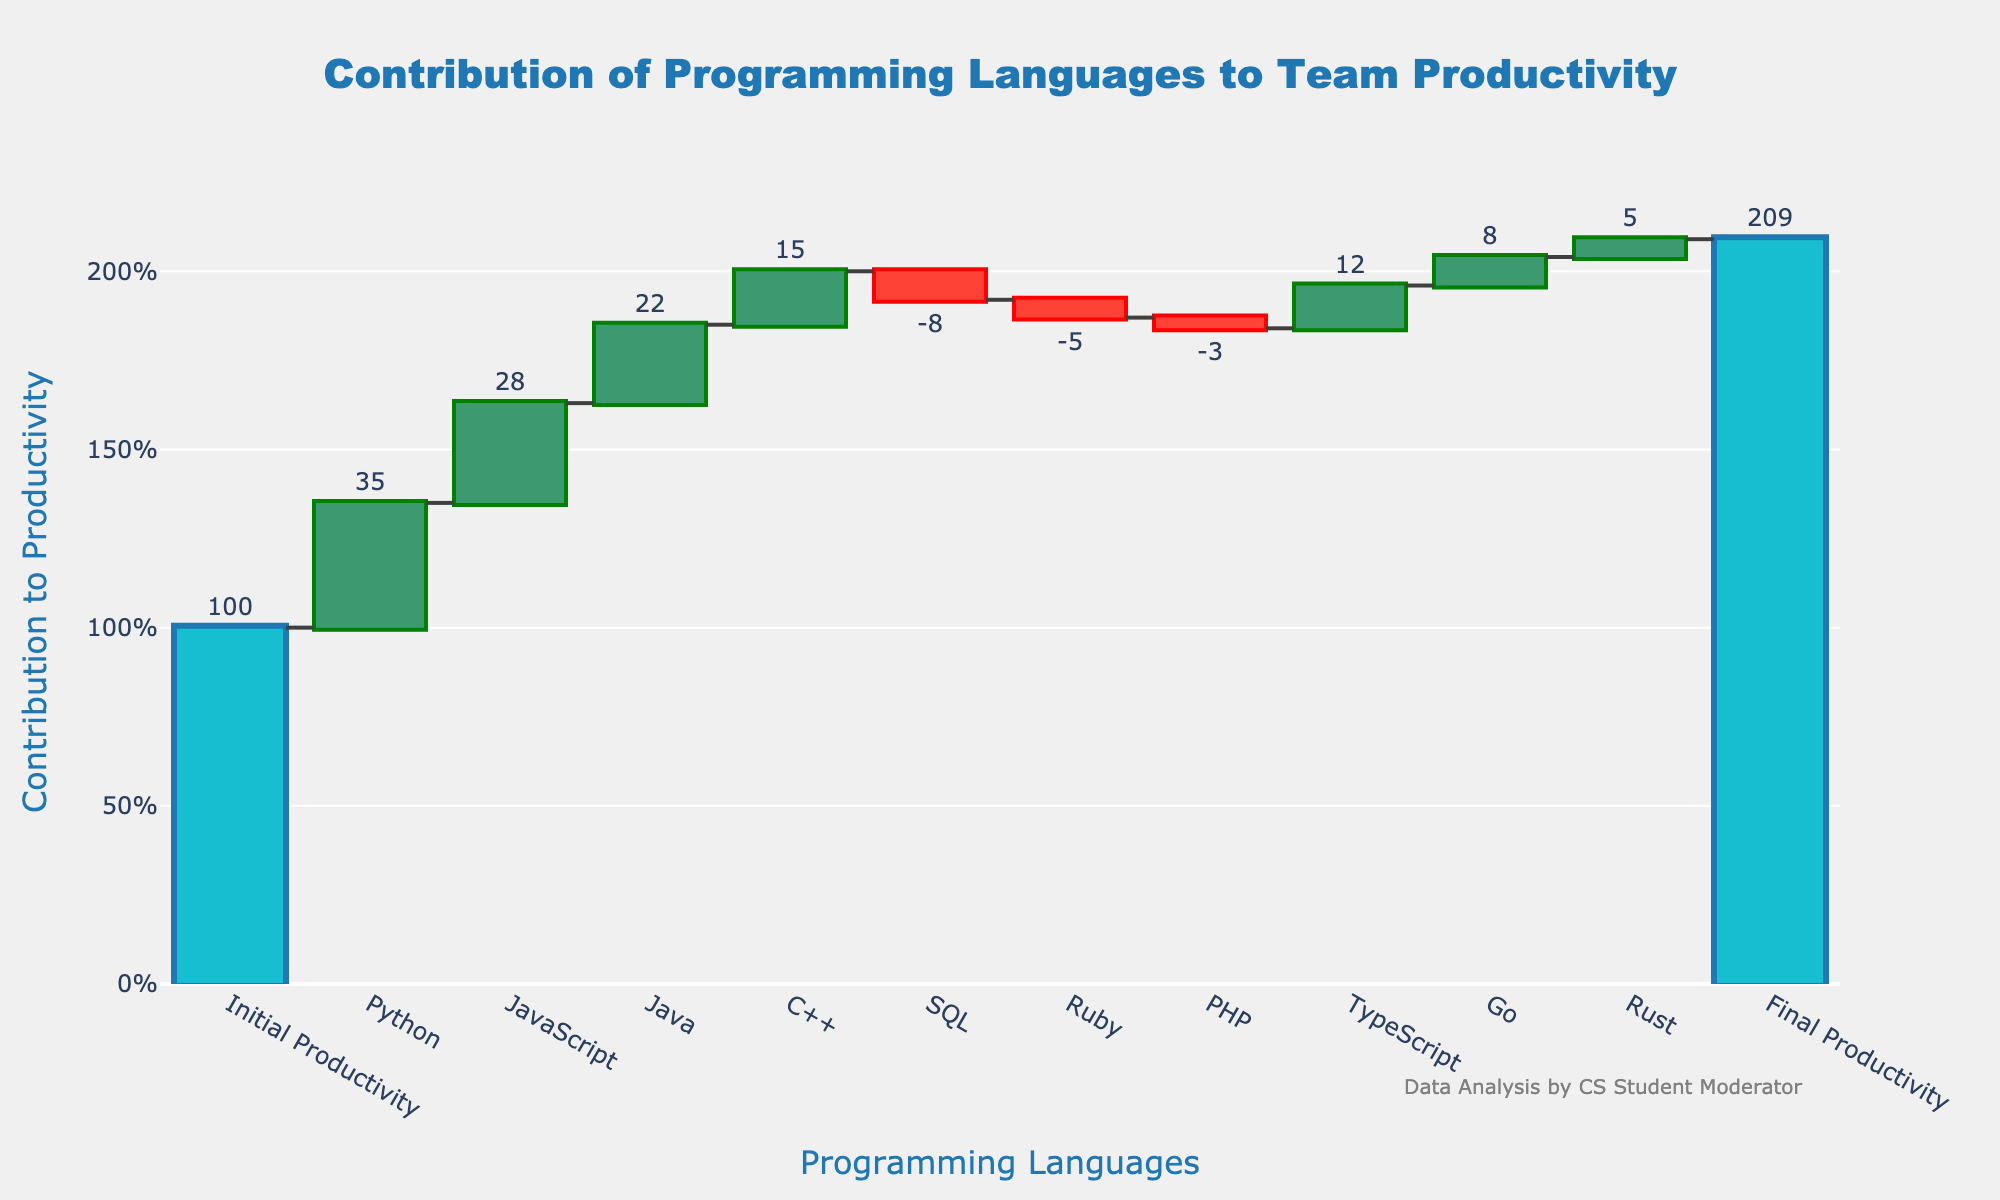What's the title of the chart? The title is usually displayed at the top of the chart. In this case, it states "Contribution of Programming Languages to Team Productivity."
Answer: Contribution of Programming Languages to Team Productivity How many programming languages contributed positively to productivity? To determine this, count the languages with a positive contribution. Listed with a '+' sign are Python, JavaScript, Java, TypeScript, Go, and Rust.
Answer: 6 Which language had the highest negative impact on productivity? The language with the most negative impact will have the largest negative value. SQL contributed -8, which is the greatest negative value.
Answer: SQL What is the difference in contribution between Python and JavaScript? Python's contribution is 35, and JavaScript's is 28. Subtract the smaller from the larger: 35 - 28.
Answer: 7 How does the decrease in productivity from SQL compare to Ruby? SQL decreased productivity by 8, and Ruby by 5. SQL's impact is 3 higher than Ruby's, calculated as 8 - 5.
Answer: 3 What was the team's final productivity value? The final productivity value is indicated as the cumulative total at the end of the Waterfall Chart, labeled "Final Productivity."
Answer: 209 Which language had the second-largest positive contribution to productivity? First, identify the largest positive contributor (Python at 35), then find the second-largest (JavaScript at 28).
Answer: JavaScript By how much did TypeScript increase productivity compared to Go? TypeScript's contribution is 12, and Go's is 8. Subtract Go's contribution from TypeScript's: 12 - 8.
Answer: 4 How many languages had a negative impact on productivity? Count the languages listed with a '-' sign. These are SQL, Ruby, and PHP.
Answer: 3 What was the initial productivity value before incorporating any programming languages? The initial productivity value is stated before any additions from specific languages, labeled "Initial Productivity."
Answer: 100 